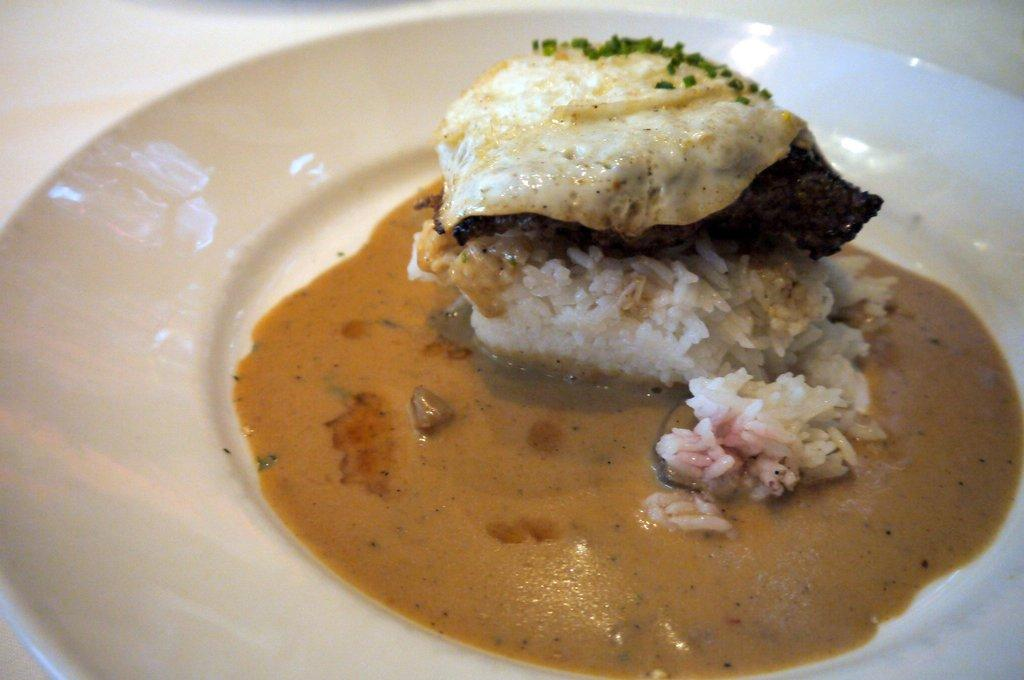What is the color of the plate in the image? The plate in the image is white. What is on the plate? The plate contains rice, an omelette, and other ingredients. What type of dish is the omelette? The omelette is not specified as a particular type in the image. What is the plate placed on? The plate is placed on an object, but the specific object is not mentioned in the facts. Are there any farms visible in the image? No, there are no farms present in the image. Can you tell me how the wren is feeling in the image? There is no wren present in the image. 